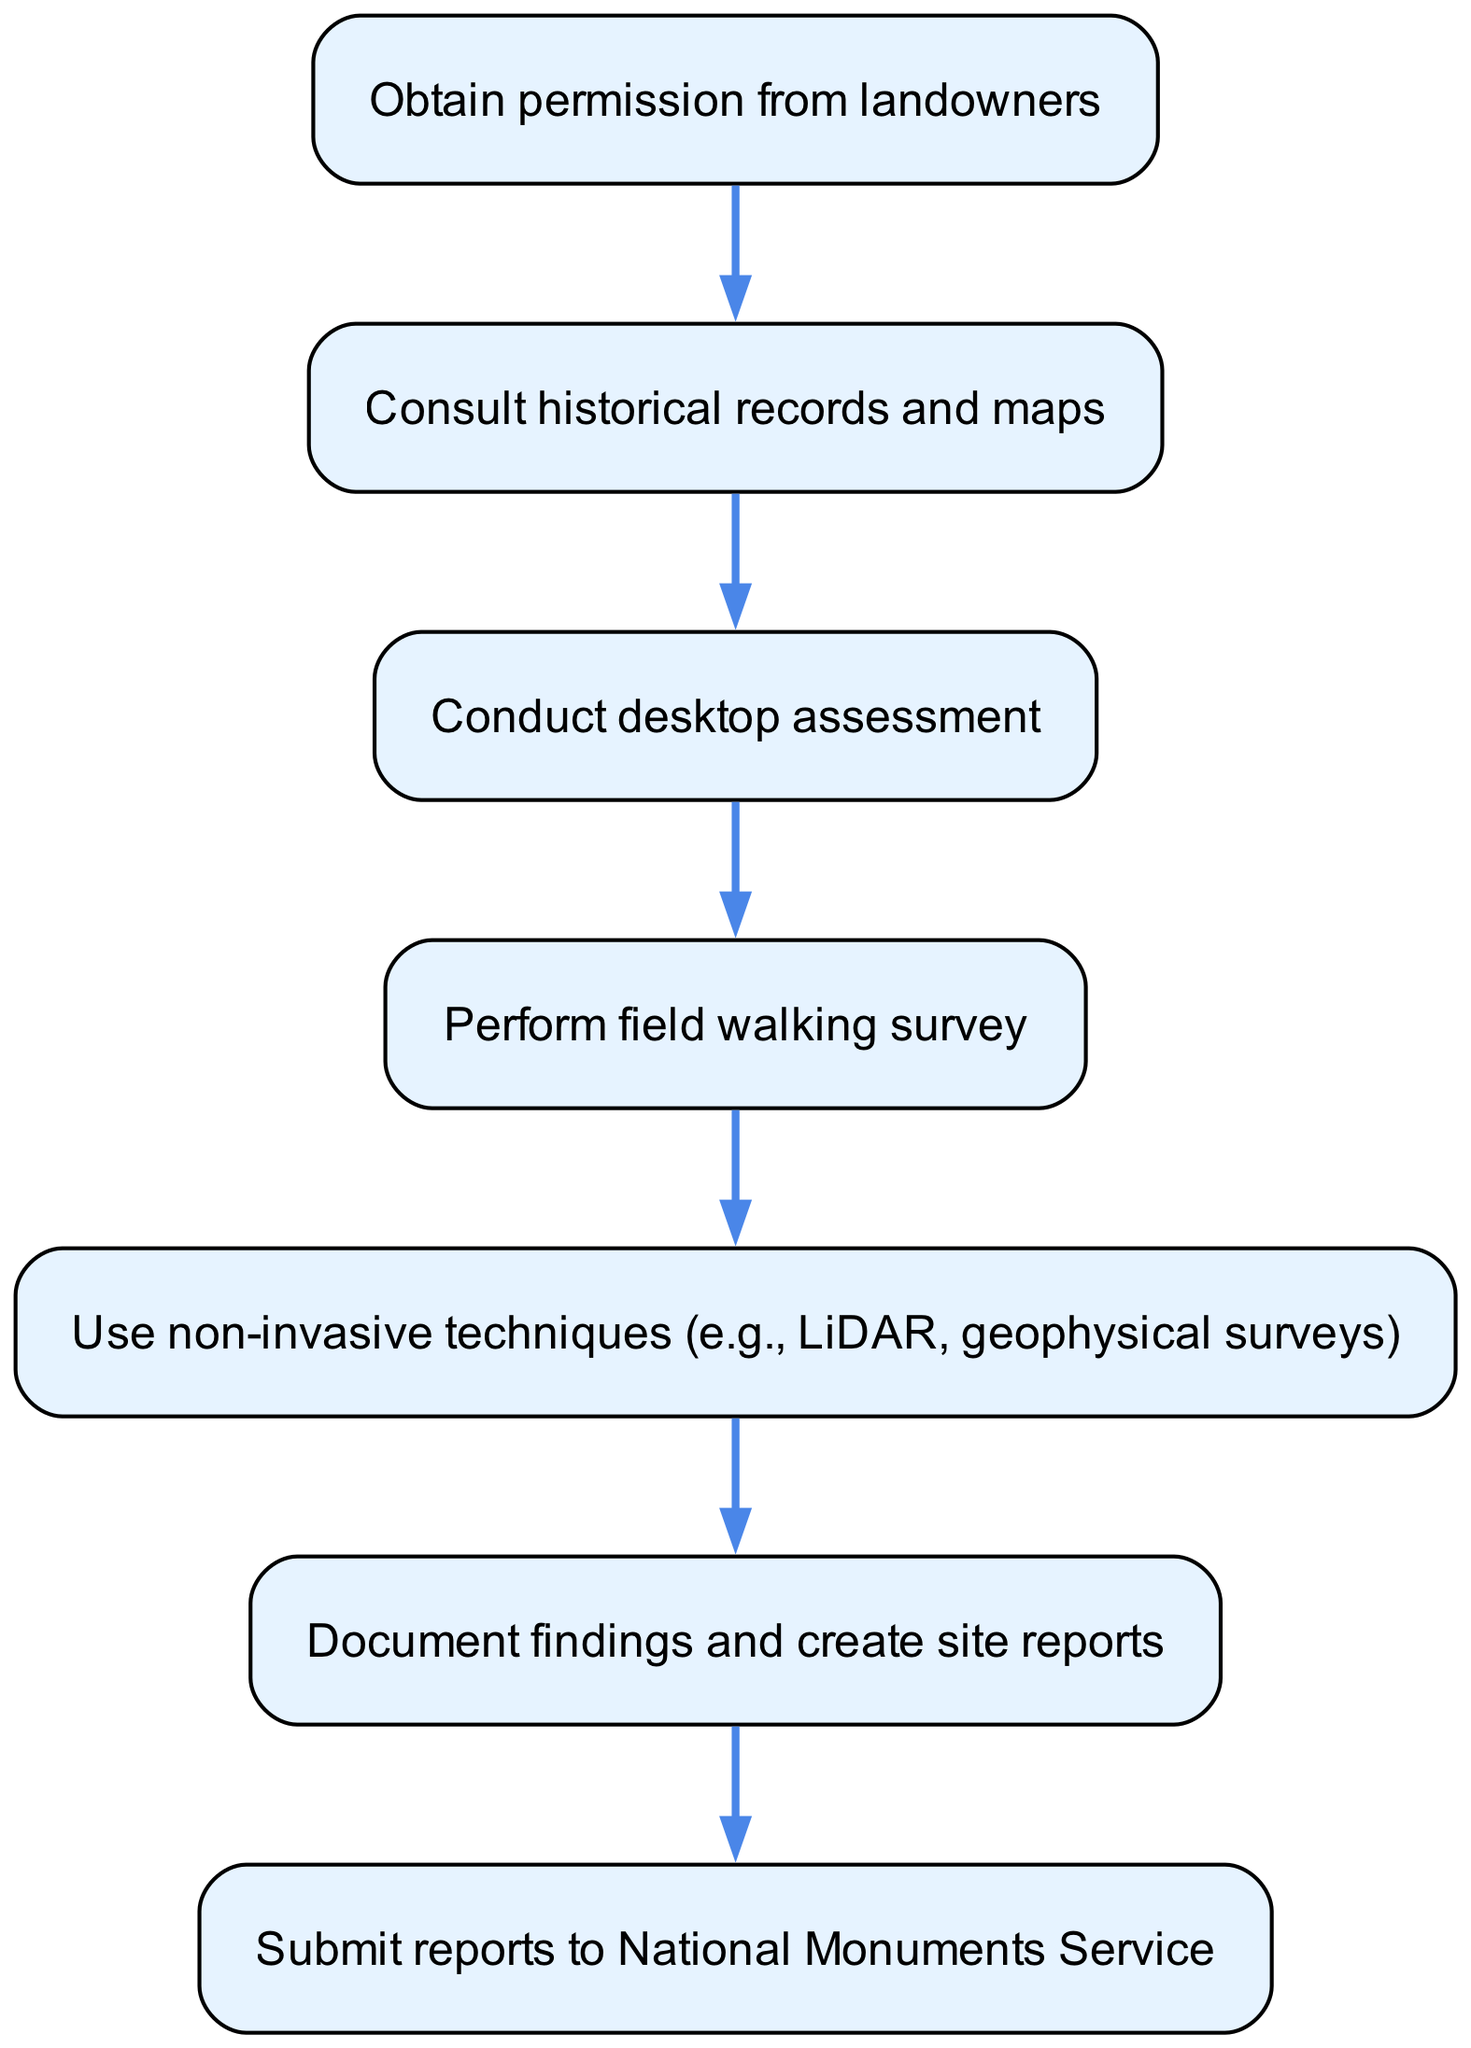What is the first step in the archaeological survey process? The diagram shows that the first step is to "Obtain permission from landowners." This is the starting node and represents the initial action before any assessment or survey can occur.
Answer: Obtain permission from landowners How many nodes are there in the flow chart? By counting the individual steps (1 to 7) represented as nodes in the diagram, we find that there are 7 nodes in total.
Answer: 7 What follows the "Conduct desktop assessment"? From the diagram, "Conduct desktop assessment" is followed by "Perform field walking survey." This indicates the sequential nature of the steps in the survey process.
Answer: Perform field walking survey Which step involves using non-invasive techniques? The step that involves using non-invasive techniques is "Use non-invasive techniques (e.g., LiDAR, geophysical surveys)." This node indicates the application of these advanced methods in the survey.
Answer: Use non-invasive techniques (e.g., LiDAR, geophysical surveys) How does one progress from documenting findings to submitting reports? According to the flow chart, the action of documenting findings leads to creating site reports, which is then followed by the step of submitting these reports to the National Monuments Service. This shows the logical progression in the workflow.
Answer: Submit reports to National Monuments Service What is the relationship between the second and third steps? The relationship between "Consult historical records and maps" (second step) and "Conduct desktop assessment" (third step) is sequential; the second step must be completed before the third step can begin, indicating a dependency in the workflow.
Answer: Sequential dependency What is the last step in the archaeological survey flow? The last step shown in the flow chart is "Submit reports to National Monuments Service," indicating that after documenting findings, this is the final action taken in the survey process.
Answer: Submit reports to National Monuments Service 